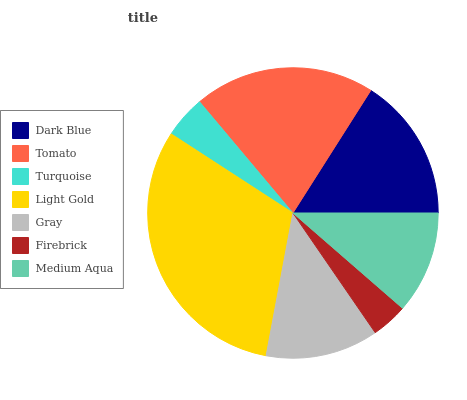Is Firebrick the minimum?
Answer yes or no. Yes. Is Light Gold the maximum?
Answer yes or no. Yes. Is Tomato the minimum?
Answer yes or no. No. Is Tomato the maximum?
Answer yes or no. No. Is Tomato greater than Dark Blue?
Answer yes or no. Yes. Is Dark Blue less than Tomato?
Answer yes or no. Yes. Is Dark Blue greater than Tomato?
Answer yes or no. No. Is Tomato less than Dark Blue?
Answer yes or no. No. Is Gray the high median?
Answer yes or no. Yes. Is Gray the low median?
Answer yes or no. Yes. Is Turquoise the high median?
Answer yes or no. No. Is Tomato the low median?
Answer yes or no. No. 